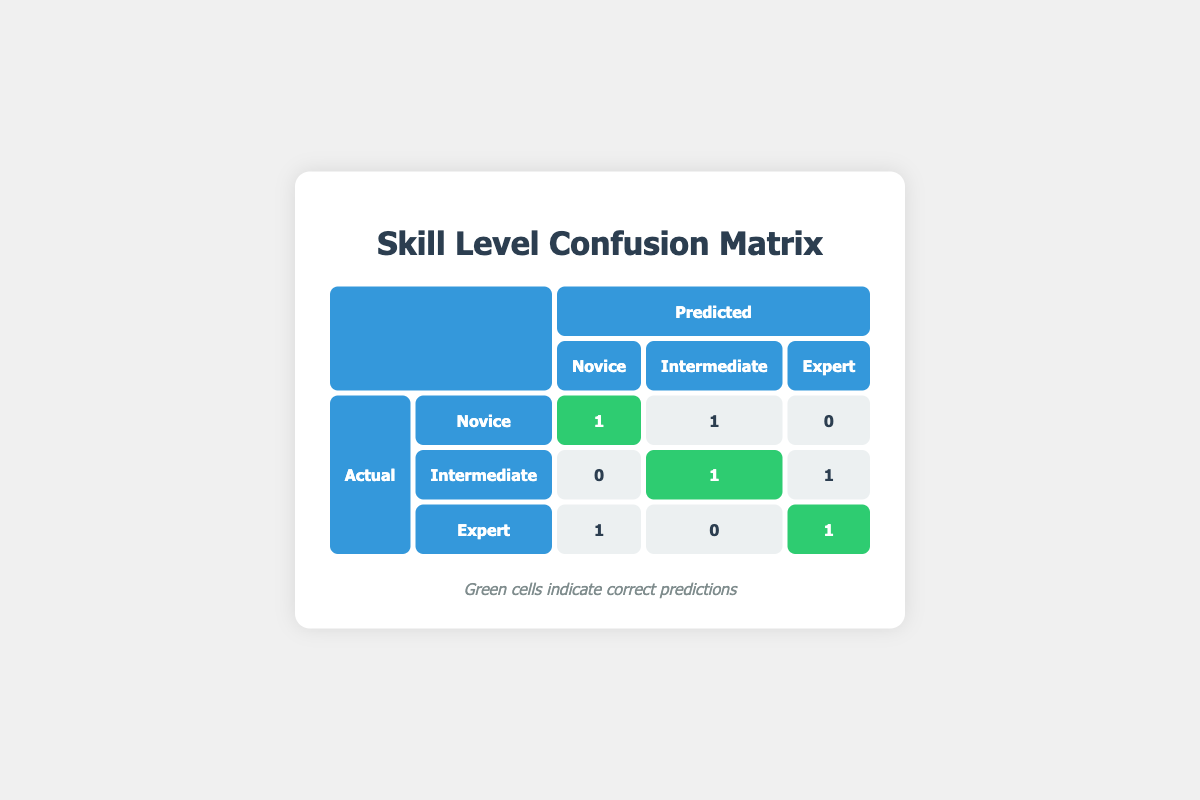What is the total number of correct predictions for Novice players? In the table, the correct prediction for Novice is indicated in the green cell under the Novice row, which shows a value of 1. Therefore, the total number of correct predictions for Novice players is 1.
Answer: 1 How many players were incorrectly predicted as Novice? In the table under the Novice column, there is 1 incorrect prediction (Bob in the Novice row predicted as Intermediate) and 1 from the Expert row (Fiona predicted as Novice). So, combining both gives a total of 2 players incorrectly predicted as Novice.
Answer: 2 What is the sum of the correct predictions for Intermediate and Expert players? For Intermediate, there is 1 correct prediction (Charlie), and for Expert, there is also 1 correct prediction (Ethan). Adding these two amounts together gives 1 + 1 = 2.
Answer: 2 Is it true that all Expert predictions were correct? In the Expert row, the correct prediction is 1 (Ethan), but Fiona was incorrectly predicted as Novice. Therefore, not all Expert predictions were correct, making the answer false.
Answer: False What is the average number of correct predictions across all skill levels? The correct predictions are 1 (Novice) + 1 (Intermediate) + 1 (Expert) = 3 correct predictions in total. There are 3 skill levels, so the average is 3/3 = 1.
Answer: 1 